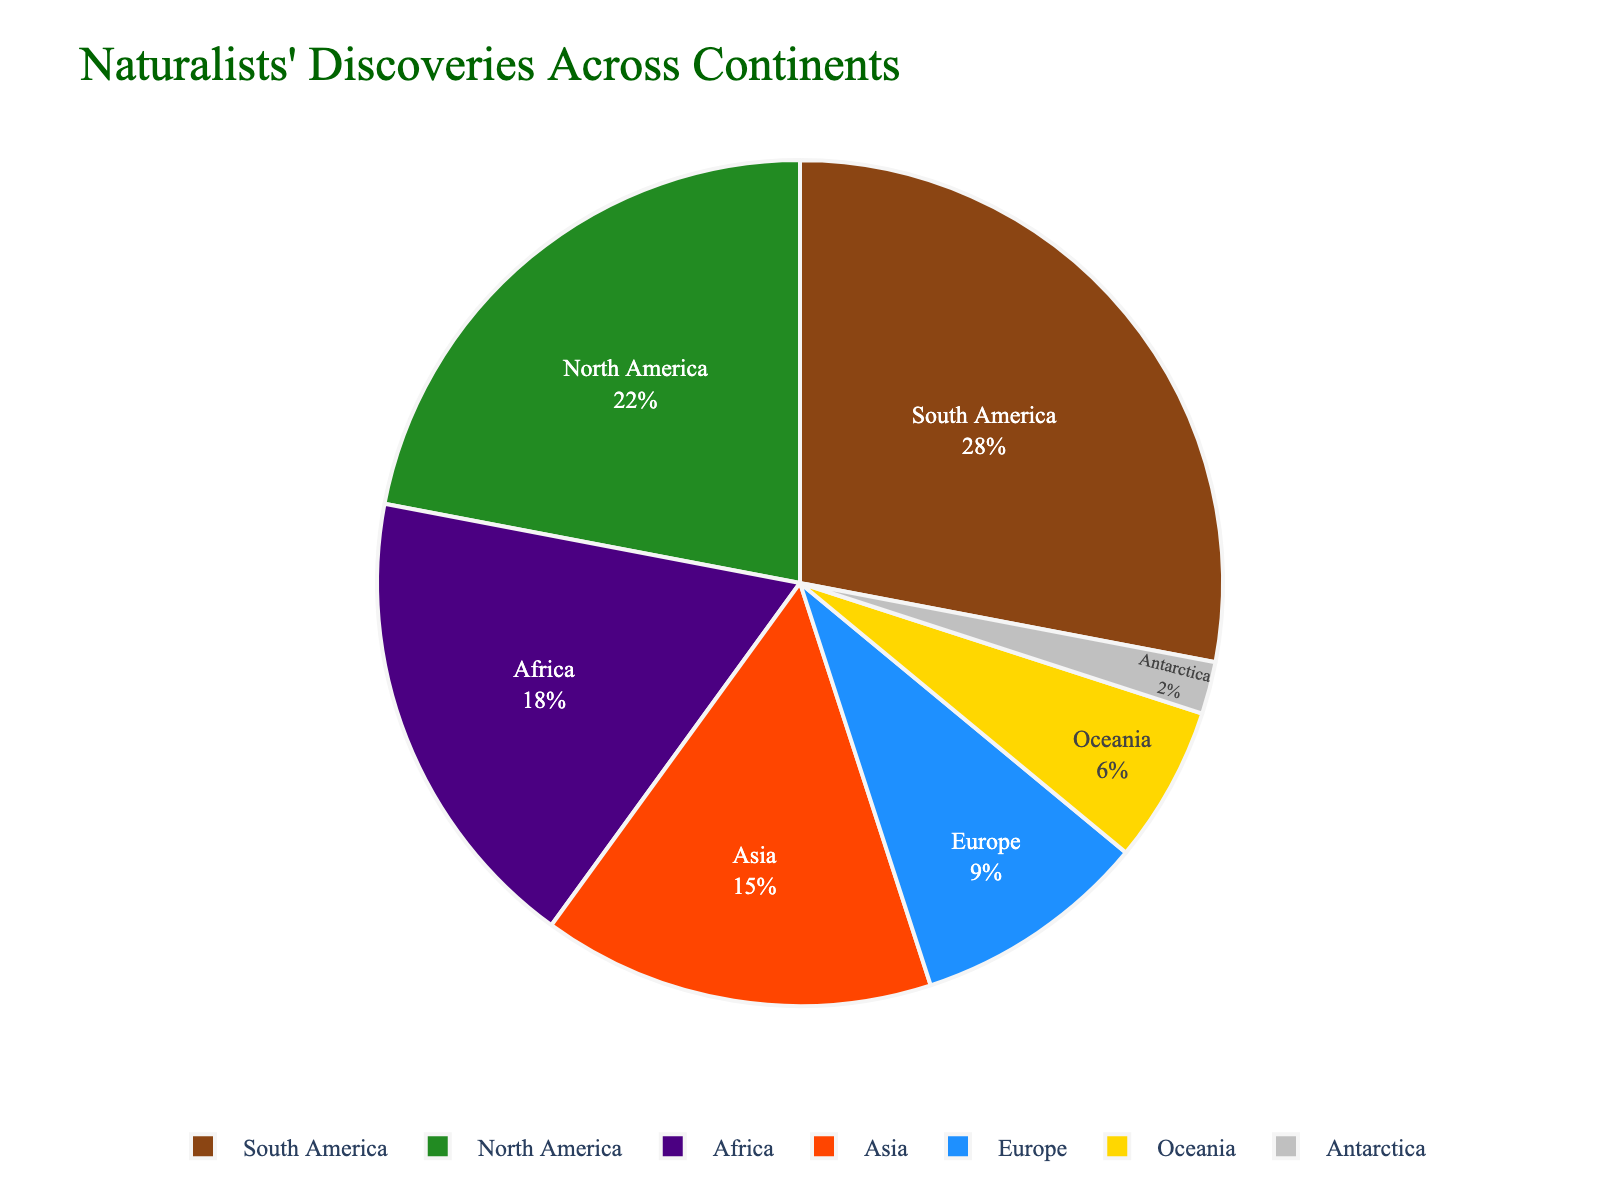Which continent has the highest proportion of discoveries? By looking at the largest segment in the pie chart, we can see that South America has the highest proportion.
Answer: South America Which continents have a proportion of discoveries less than 10%? The smaller segments are Europe, Oceania, and Antarctica. These all have proportions of discoveries less than 10%.
Answer: Europe, Oceania, Antarctica What is the total proportion of discoveries in Africa and Asia combined? Add the proportions for Africa (18%) and Asia (15%). 18 + 15 = 33%
Answer: 33% Is the proportion of discoveries in North America greater than that in Europe? Compare the segment sizes: North America (22%) is larger than Europe (9%).
Answer: Yes Which continent has a proportion of discoveries closest to 20%? North America has a proportion of 22%, which is closest to 20%.
Answer: North America What is the difference in the proportion of discoveries between South America and Antarctica? Subtract the proportion of Antarctica (2%) from South America (28%). 28 - 2 = 26%
Answer: 26% How many continents have a proportion of discoveries higher than 15%? South America (28%), North America (22%), and Africa (18%) all have more than 15%. That's 3 continents.
Answer: 3 If you combine the proportions for Europe and Oceania, do they exceed 15%? Add the proportions for Europe (9%) and Oceania (6%). 9 + 6 = 15%, which does not exceed 15%.
Answer: No What color represents the continent with the second highest proportion of discoveries? The second largest segment represents North America, which is colored in green.
Answer: Green 